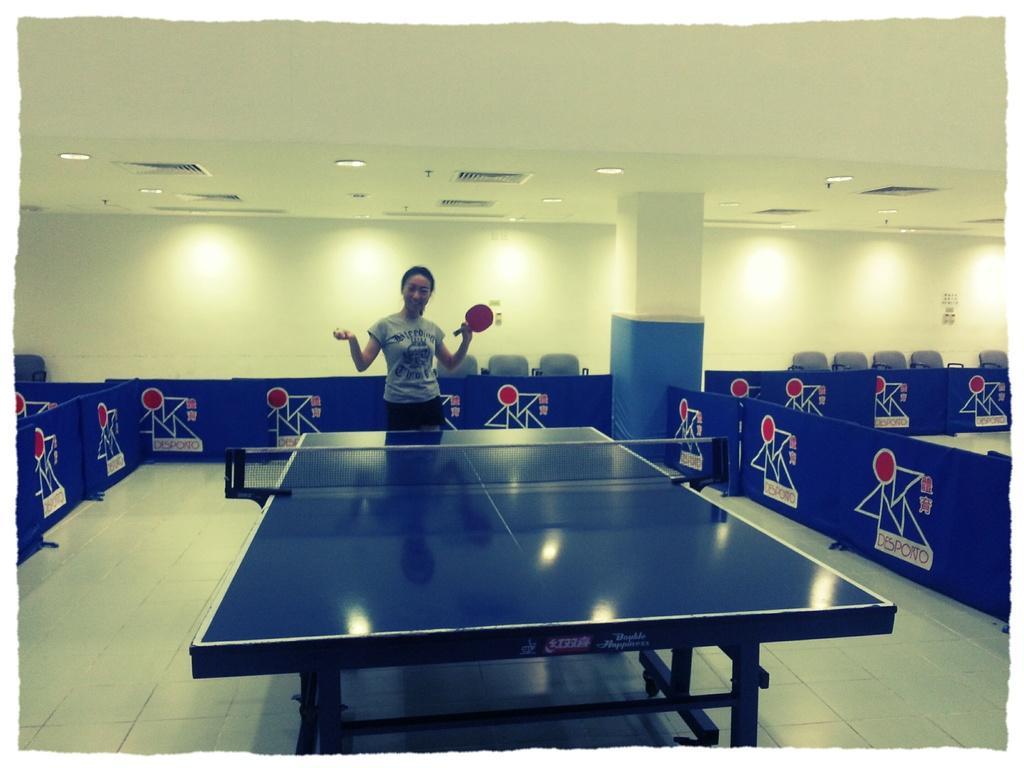In one or two sentences, can you explain what this image depicts? In this picture we can see a table tennis table on the floor, posters, women holding a table tennis bat with her hand and at the back of her we can see chairs, pillar, lights, some objects and the wall. 